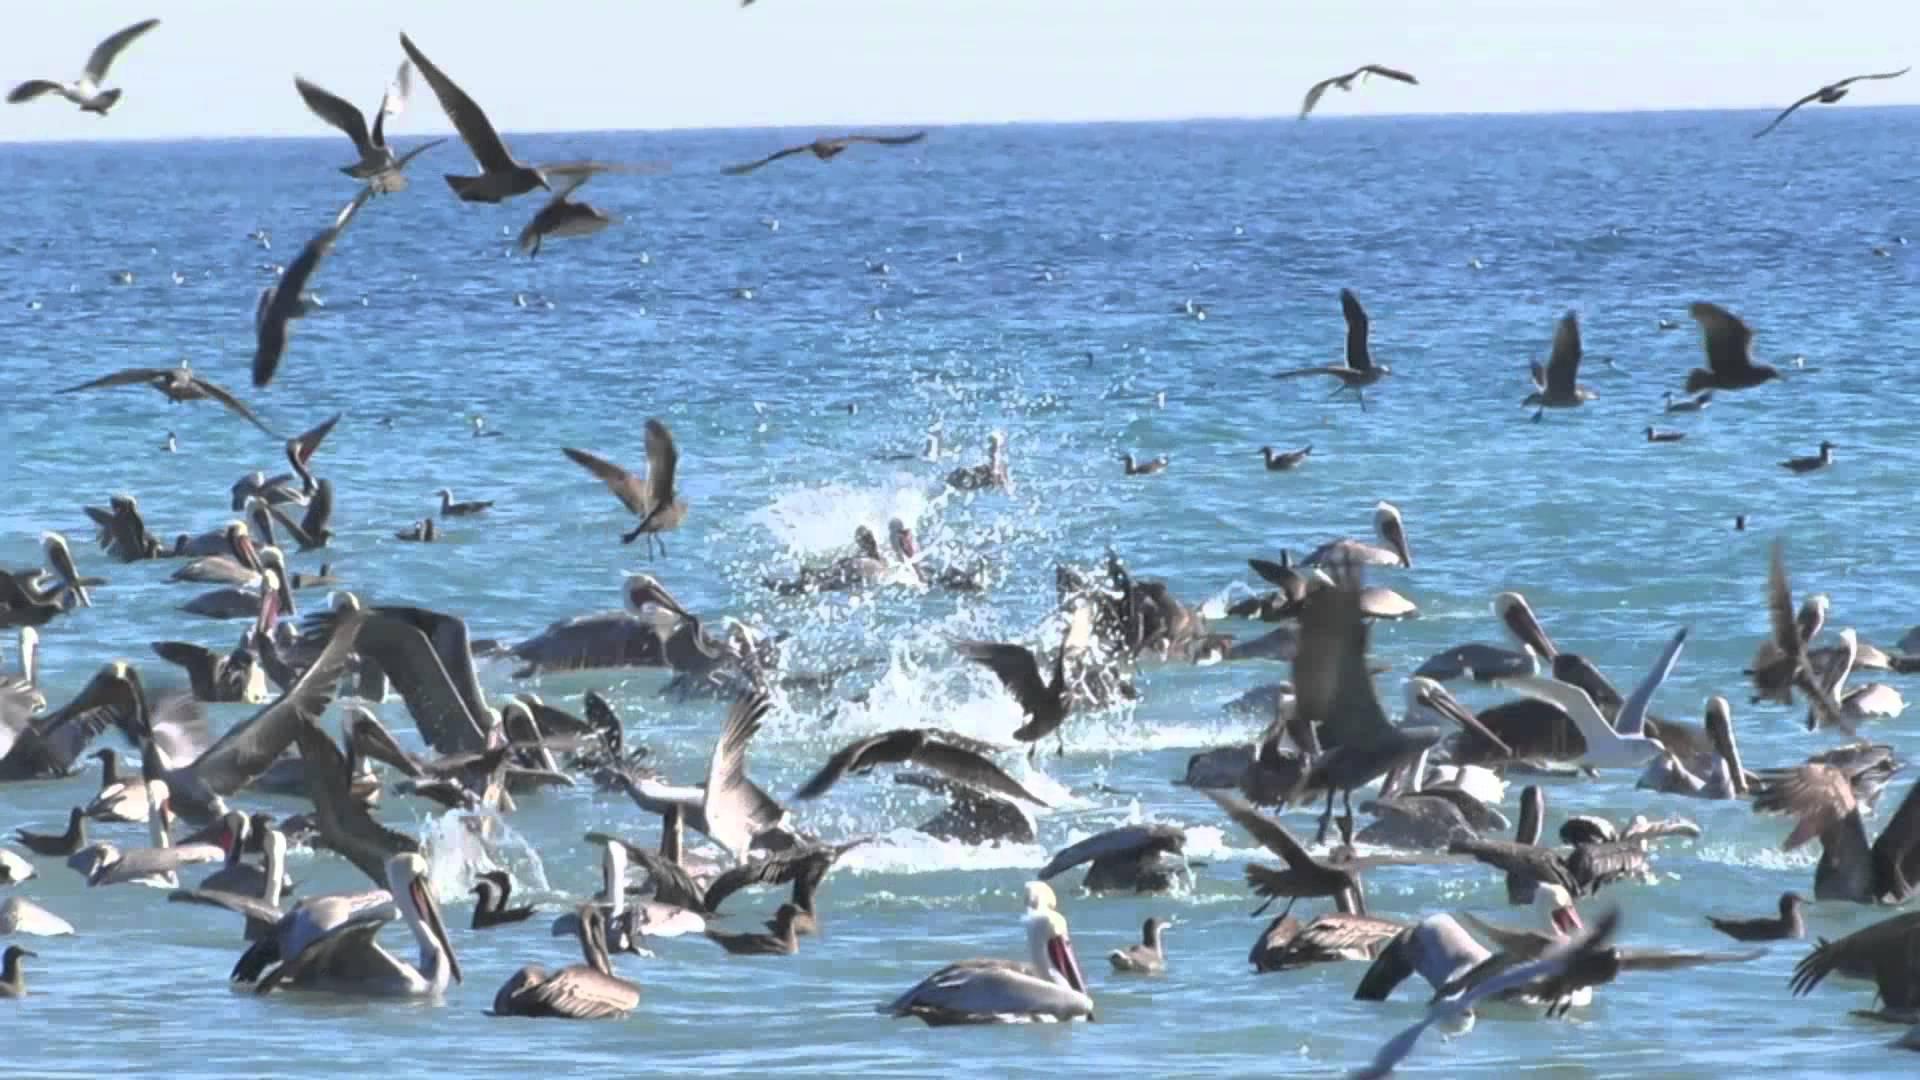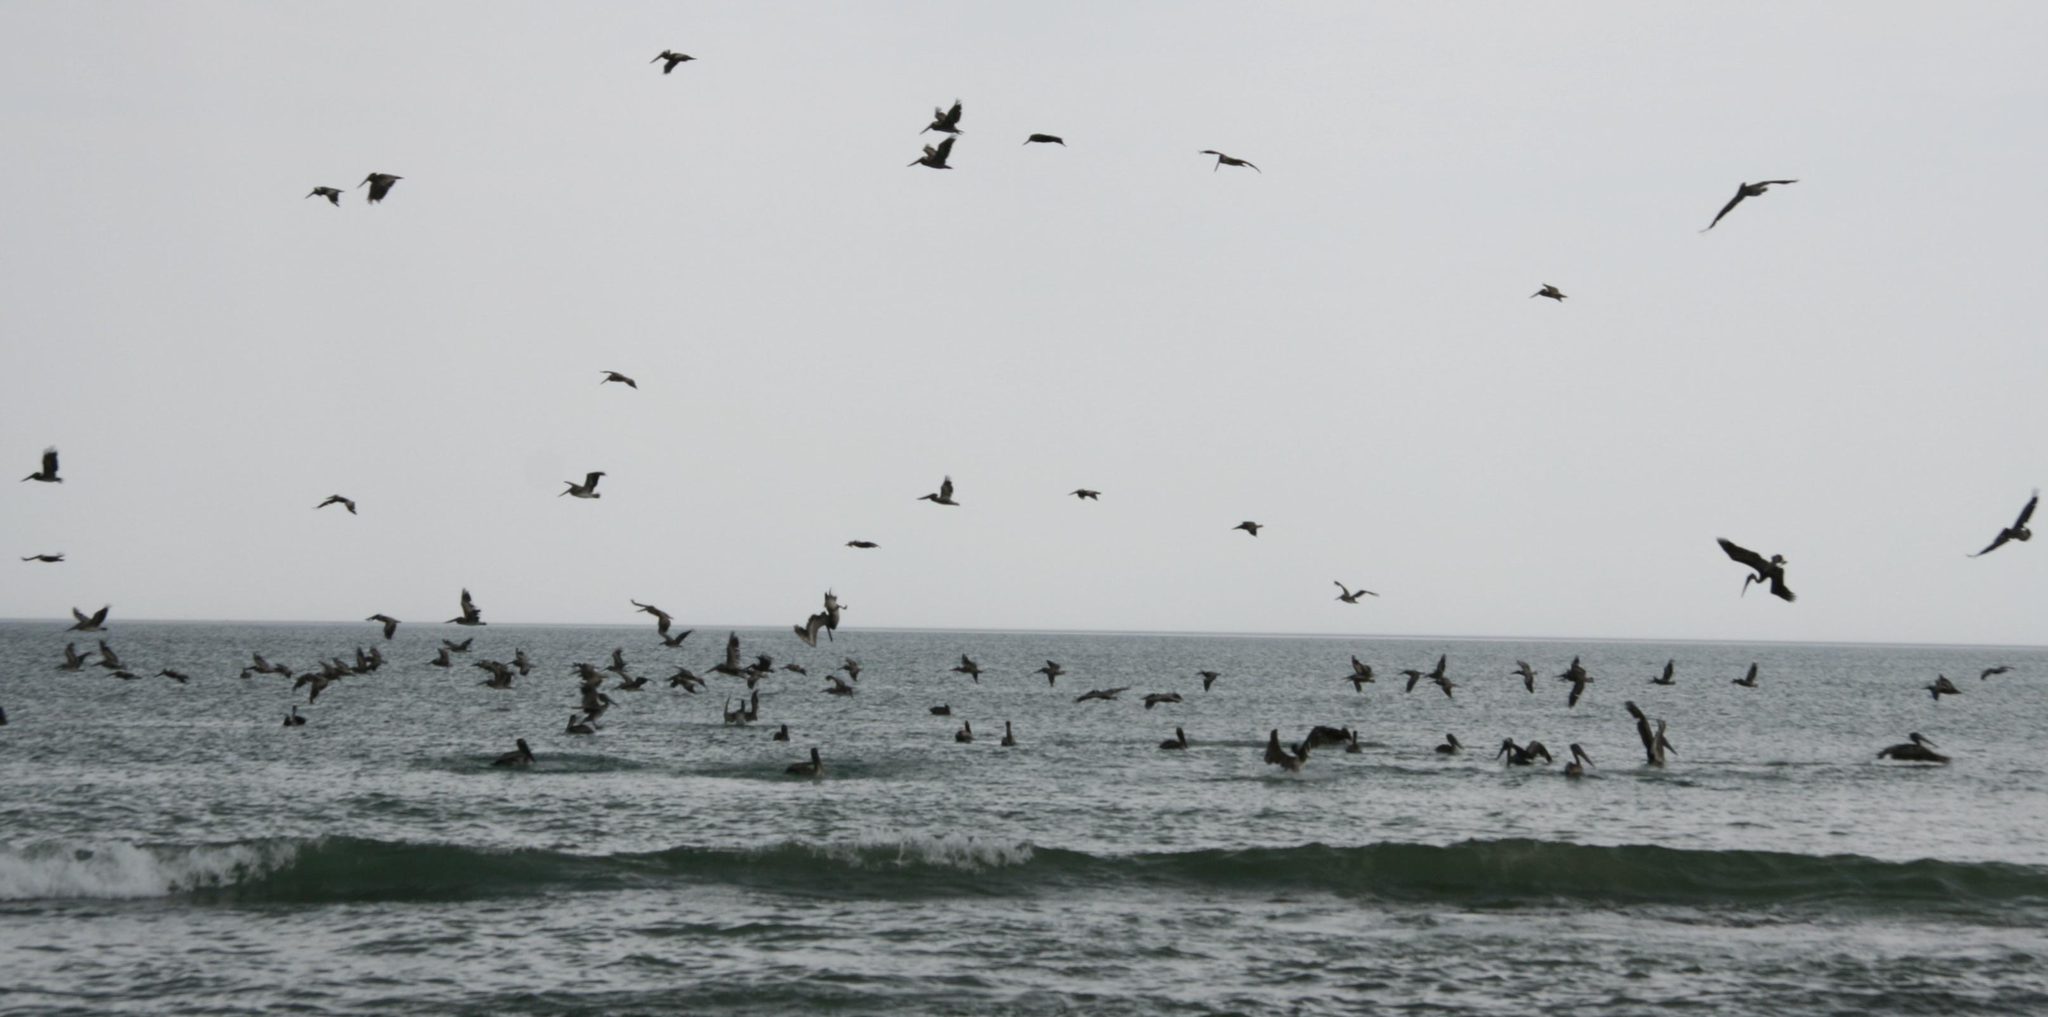The first image is the image on the left, the second image is the image on the right. For the images displayed, is the sentence "One image contains less than 5 flying birds." factually correct? Answer yes or no. No. The first image is the image on the left, the second image is the image on the right. For the images shown, is this caption "Four or fewer birds are flying through the air in one image." true? Answer yes or no. No. 